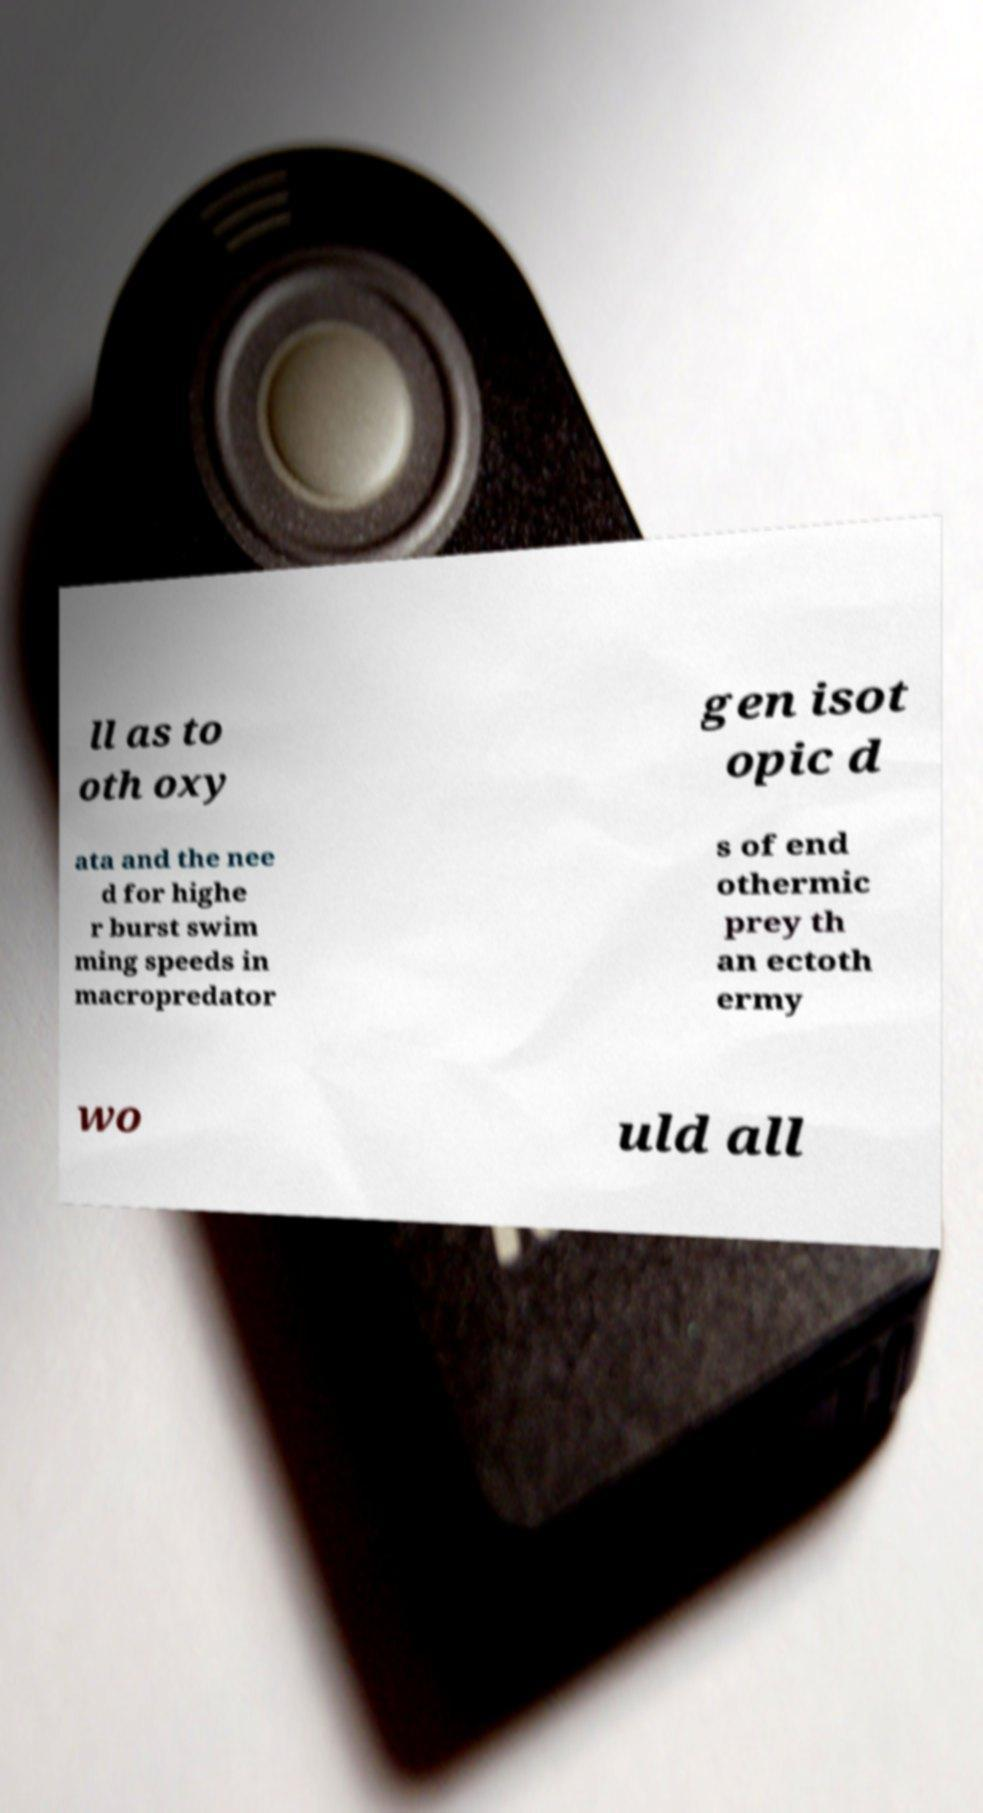What messages or text are displayed in this image? I need them in a readable, typed format. ll as to oth oxy gen isot opic d ata and the nee d for highe r burst swim ming speeds in macropredator s of end othermic prey th an ectoth ermy wo uld all 